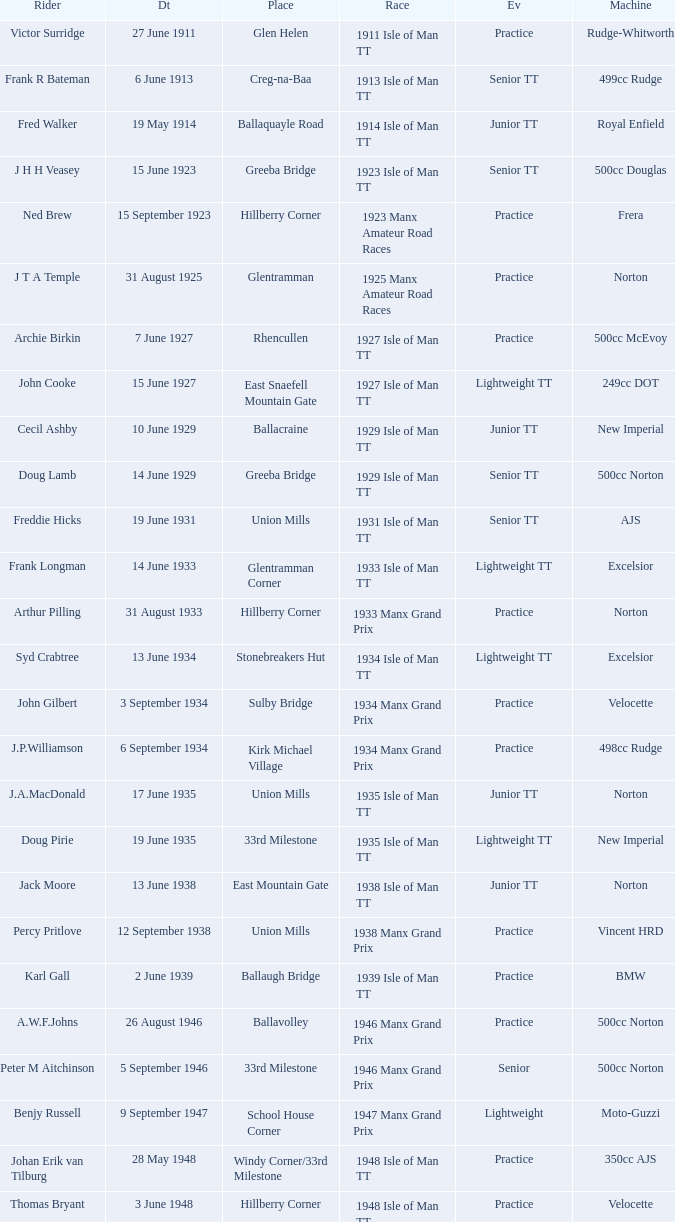Harry l Stephen rides a Norton machine on what date? 8 June 1953. 